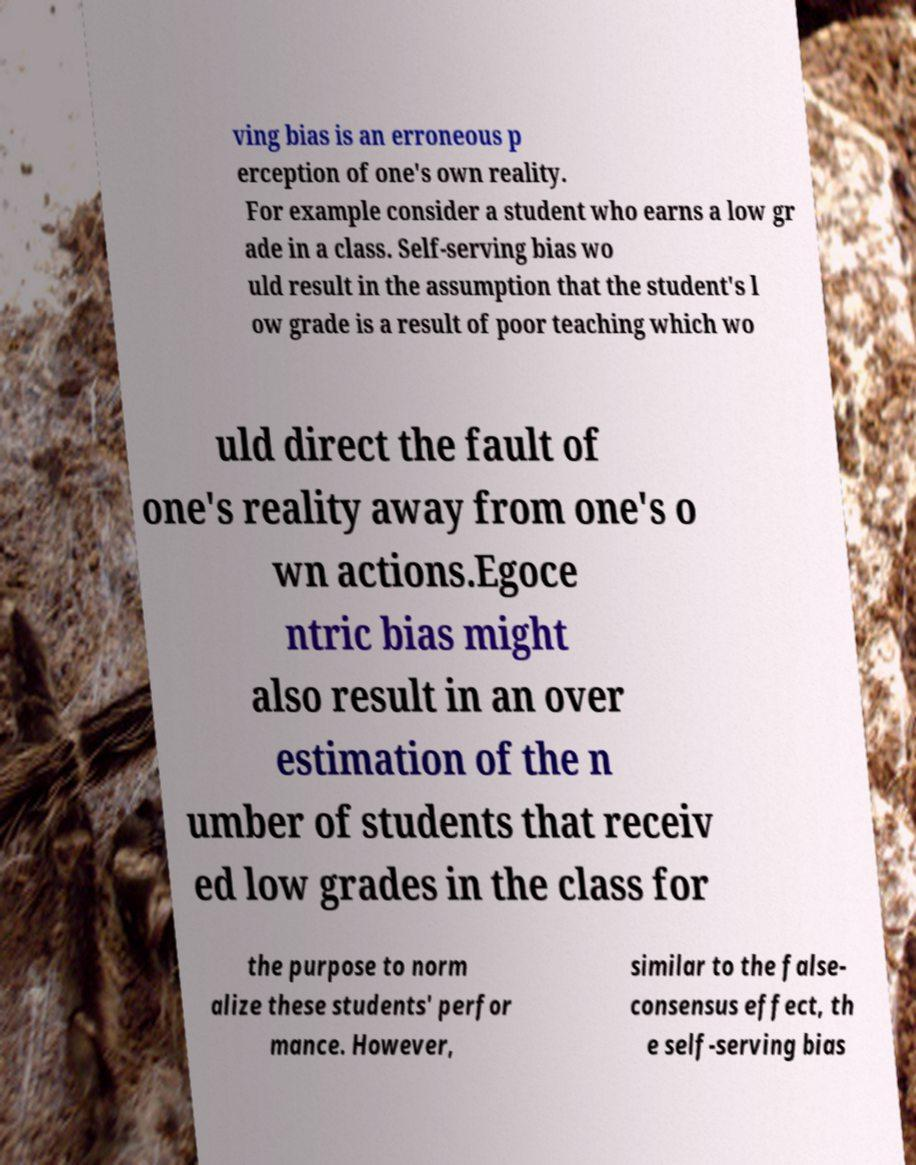Please identify and transcribe the text found in this image. ving bias is an erroneous p erception of one's own reality. For example consider a student who earns a low gr ade in a class. Self-serving bias wo uld result in the assumption that the student's l ow grade is a result of poor teaching which wo uld direct the fault of one's reality away from one's o wn actions.Egoce ntric bias might also result in an over estimation of the n umber of students that receiv ed low grades in the class for the purpose to norm alize these students' perfor mance. However, similar to the false- consensus effect, th e self-serving bias 